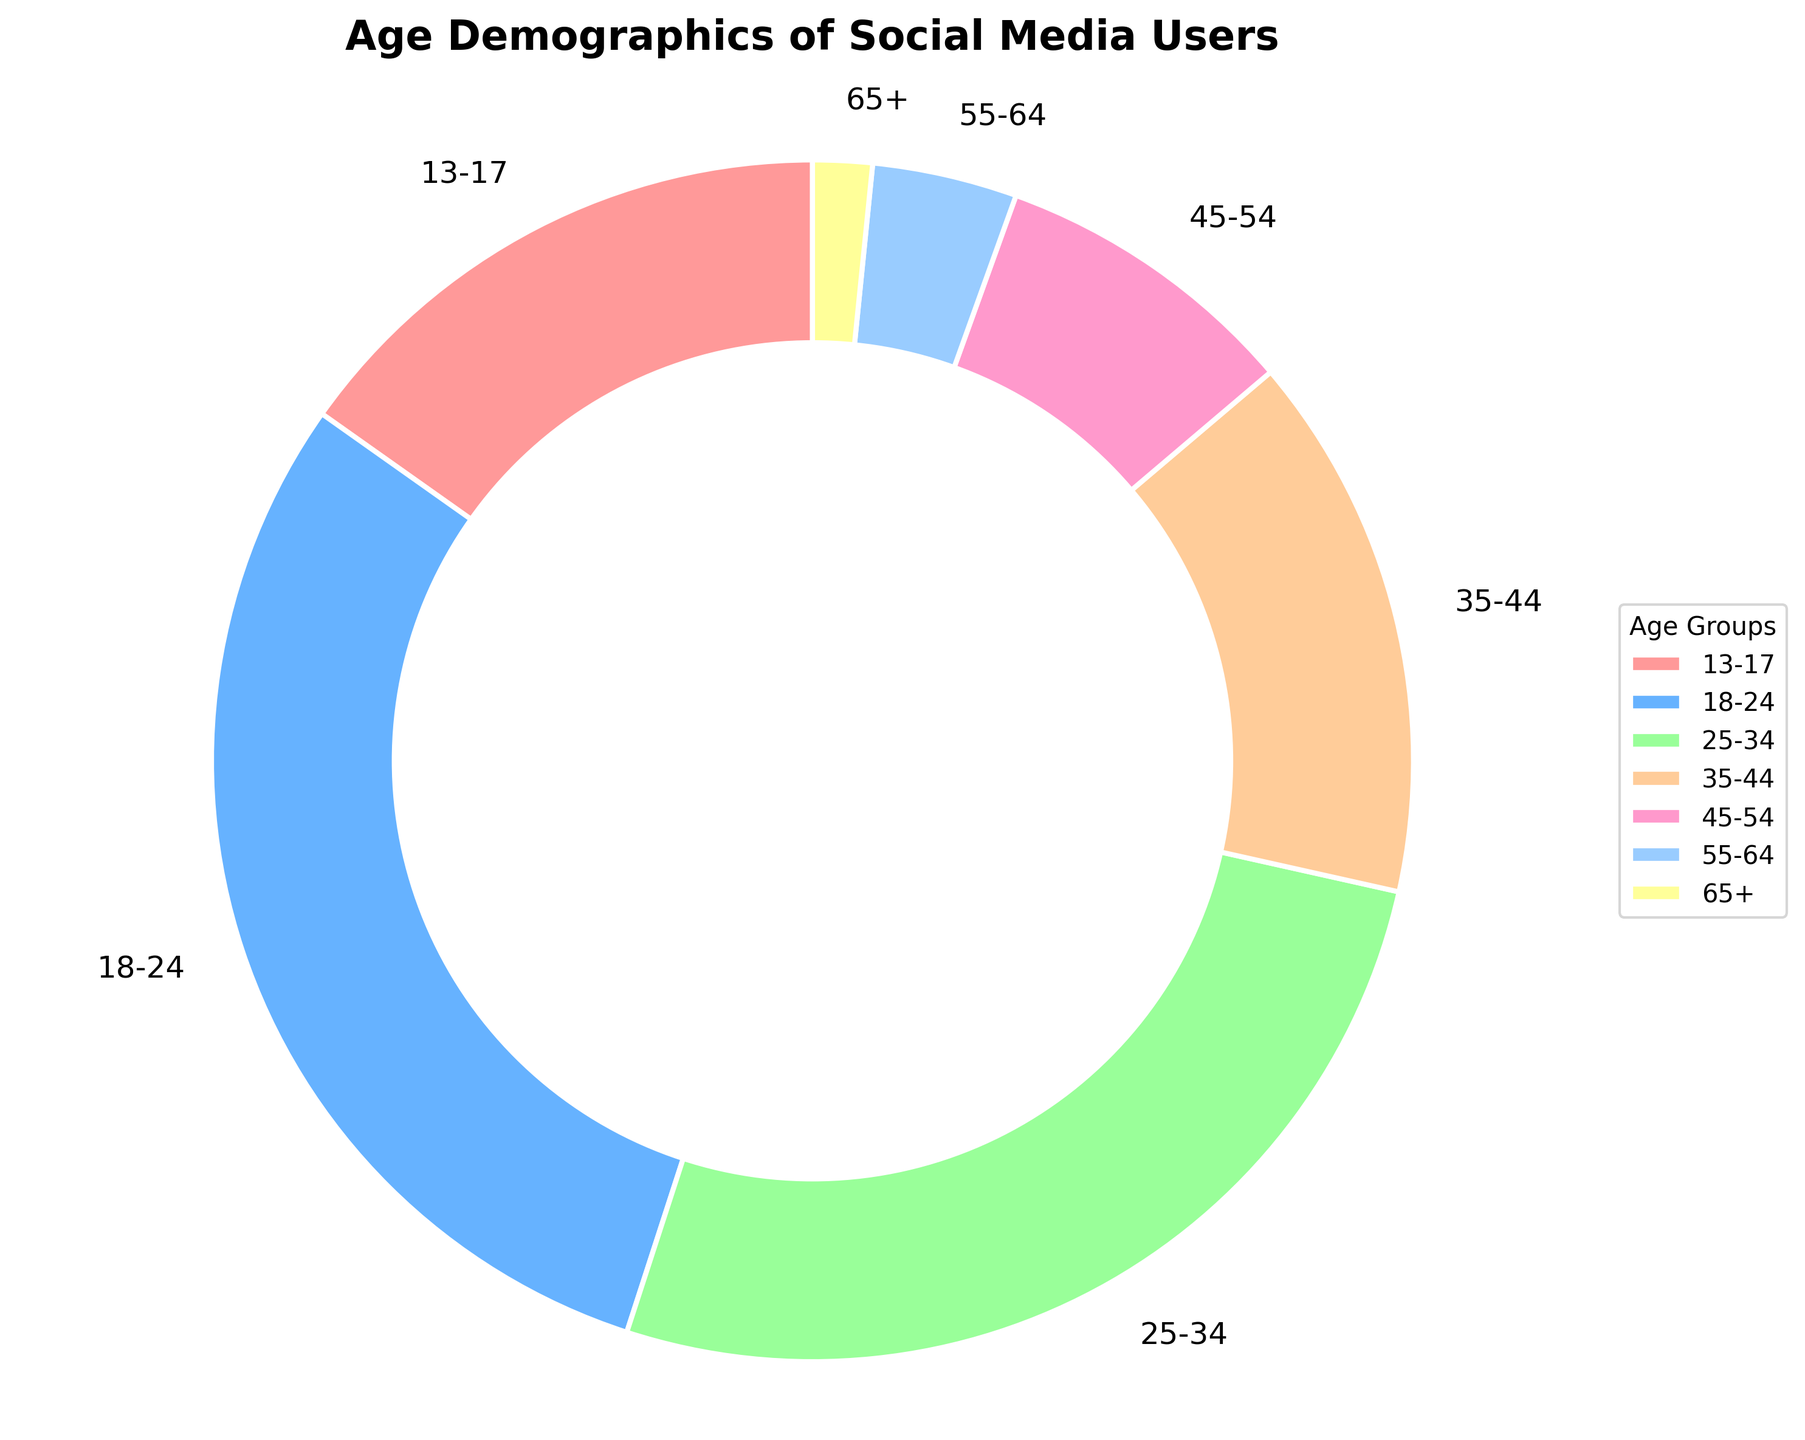What percentage of social media users are aged 18-34? To find the percentage of users aged 18-34, sum the percentages for the 18-24 and 25-34 age groups. 29.8% (18-24) + 26.5% (25-34) = 56.3%
Answer: 56.3% Which age group has the largest percentage of social media users? The pie chart shows that the 18-24 age group has the largest percentage, which is clearly marked as 29.8%.
Answer: 18-24 Compare the percentage of users in the 13-17 age group with those in the 65+ age group. Look at the percentage values for both groups. The 13-17 age group is 15.2%, and the 65+ age group is 1.6%. 15.2% is greater than 1.6%, indicating a much higher percentage of younger users.
Answer: 13-17 > 65+ Which two age groups have the closest percentages of users, and what are these percentages? Compare the percentages of all age groups to find the closest values. The 13-17 (15.2%) and 35-44 (14.7%) age groups are closest in percentage.
Answer: 13-17 and 35-44; 15.2% and 14.7% What is the combined percentage of users aged 45 and older? Sum the percentages of the age groups 45-54, 55-64, and 65+. 8.3% (45-54) + 3.9% (55-64) + 1.6% (65+) = 13.8%
Answer: 13.8% What proportion of the total is the 25-34 age group of all users? The total proportion is represented by 100%, and the 25-34 age group is 26.5% of that total. Thus, its proportion is 26.5%.
Answer: 26.5% How does the percentage of users in the 35-44 age group compare to the percentage of users in the 18-24 age group? The 35-44 age group has 14.7%, and the 18-24 age group has 29.8%. Compare these two values to see that 14.7% is less than 29.8%.
Answer: 35-44 < 18-24 What is the range between the highest and lowest percentages of social media users in the age groups? Identify the highest and lowest percentages in the chart: 29.8% (highest) for 18-24 and 1.6% (lowest) for 65+. Subtract the lowest value from the highest value: 29.8% - 1.6% = 28.2%.
Answer: 28.2% Which color represents the 55-64 age group in the chart? The pie chart uses a specific color palette for each age group. The 55-64 age group is represented by a light blue shade.
Answer: Light blue Are there more users aged 13-34 or aged 35+ on the platform? Sum the percentages of the age groups 13-34 and 35+. For 13-34: 15.2% (13-17) + 29.8% (18-24) + 26.5% (25-34) = 71.5%. For 35+: 14.7% (35-44) + 8.3% (45-54) + 3.9% (55-64) + 1.6% (65+) = 28.5%. Compare these sums to see that 13-34 has more users.
Answer: 13-34 